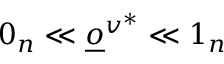Convert formula to latex. <formula><loc_0><loc_0><loc_500><loc_500>0 _ { n } \ll \underline { o } ^ { v ^ { * } } \ll 1 _ { n }</formula> 